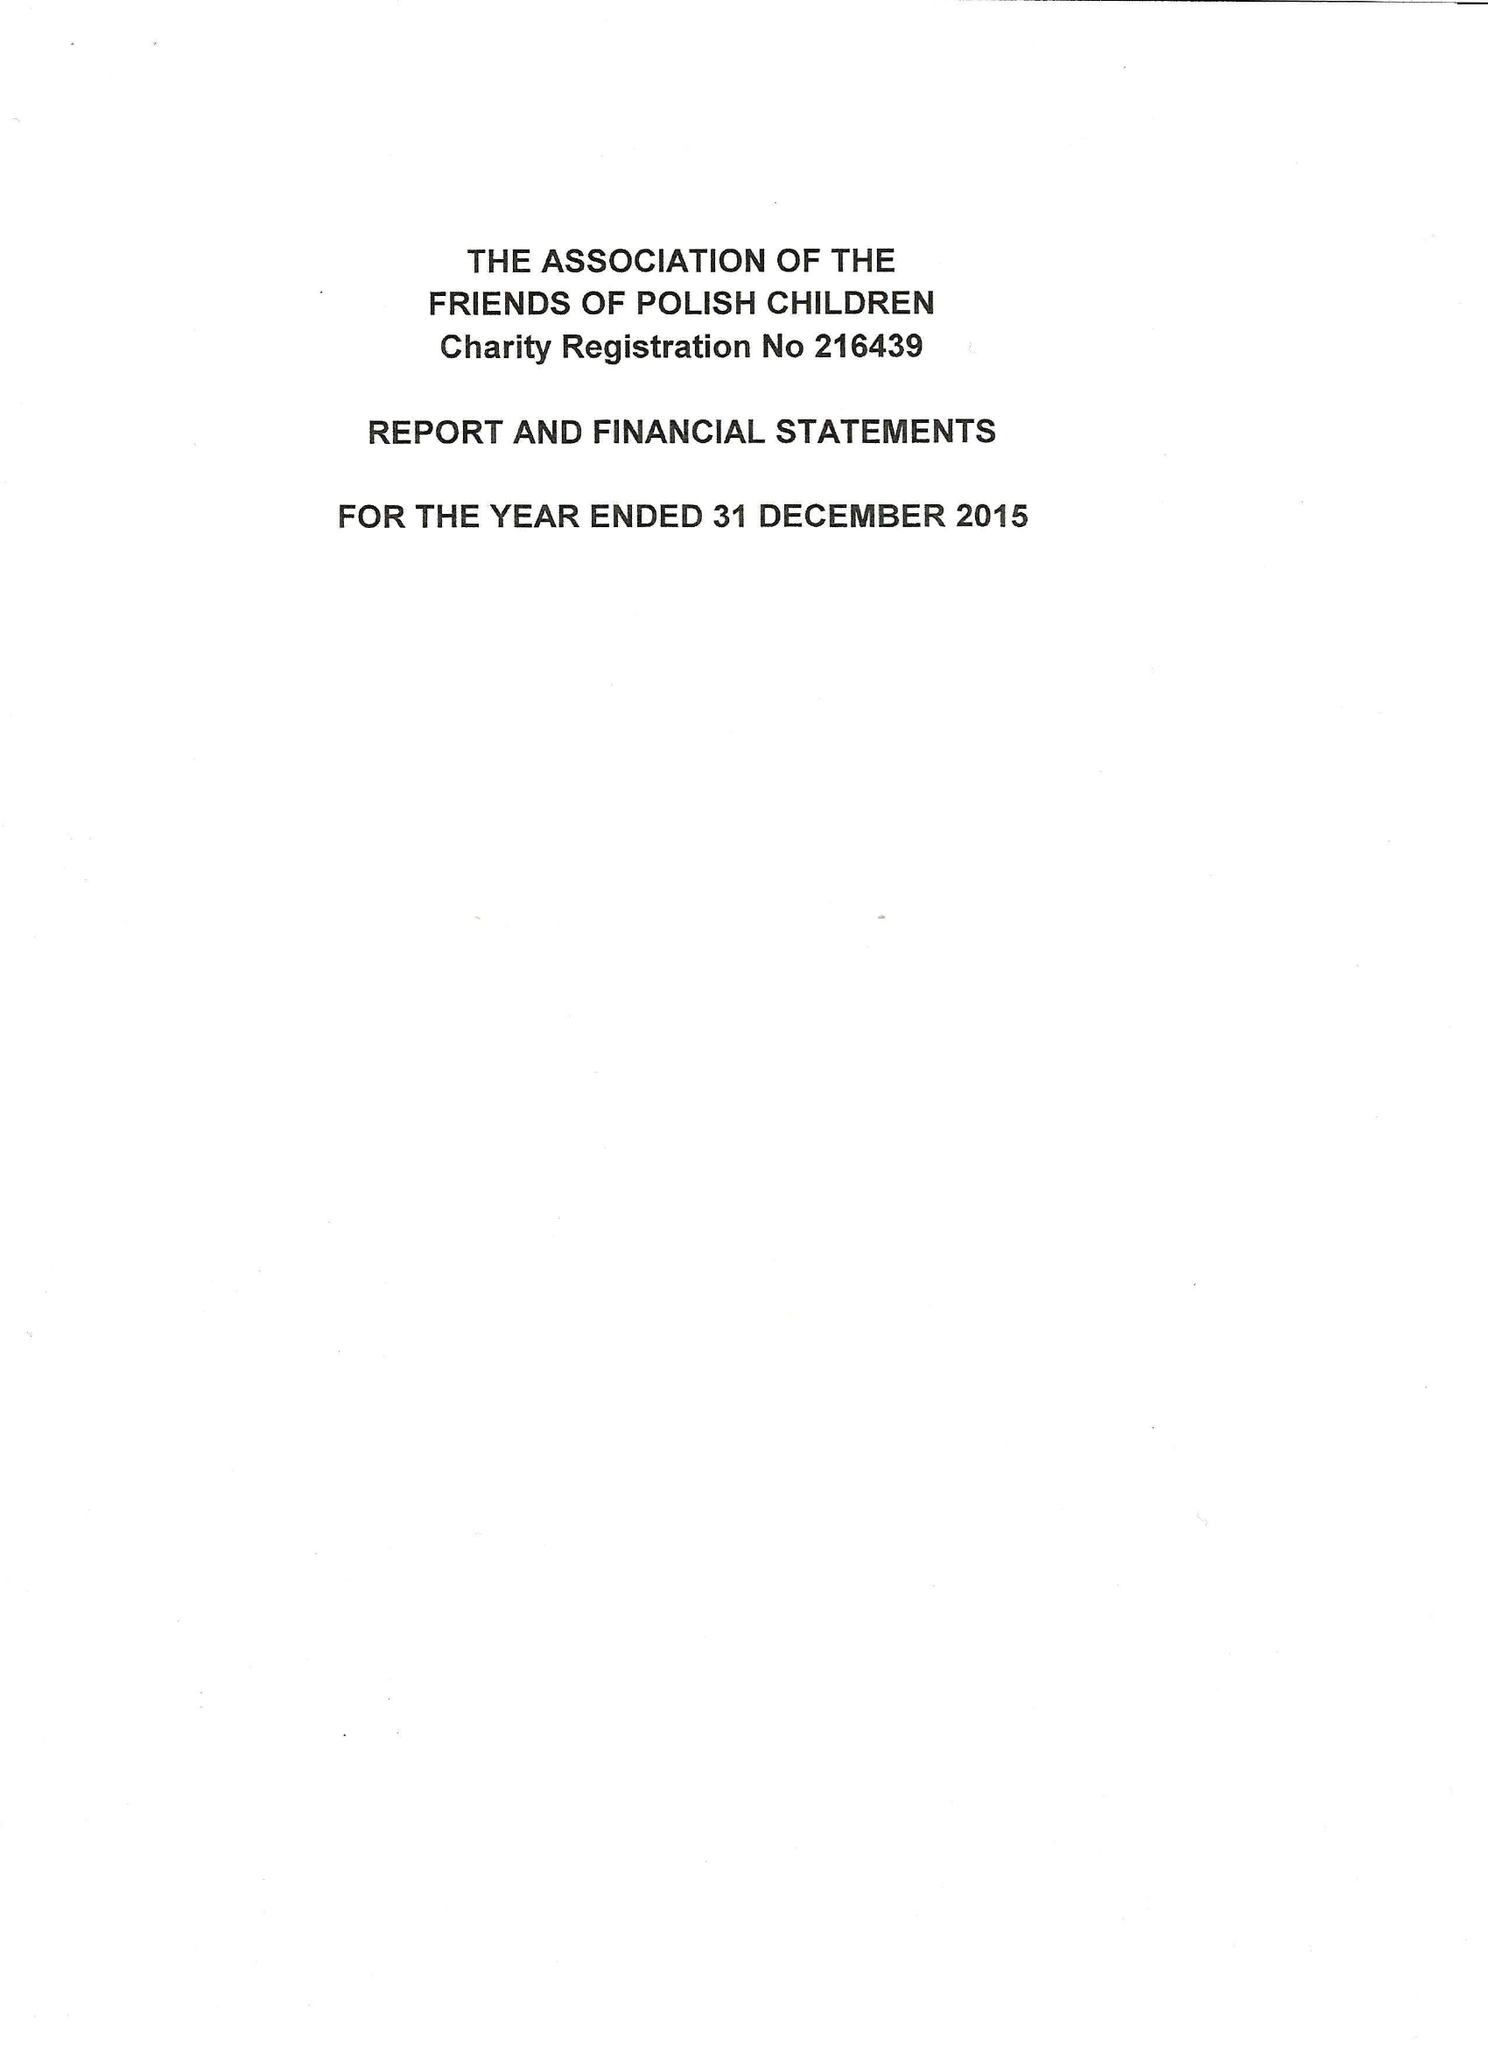What is the value for the income_annually_in_british_pounds?
Answer the question using a single word or phrase. 110329.00 